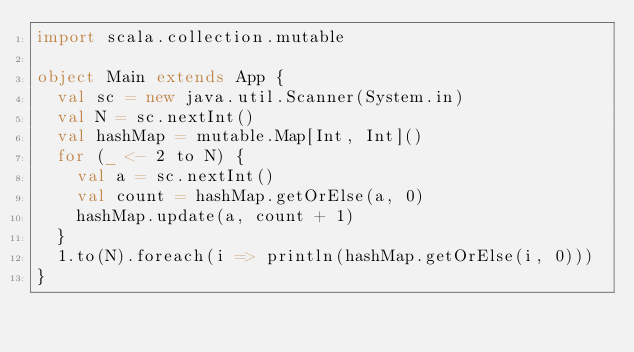Convert code to text. <code><loc_0><loc_0><loc_500><loc_500><_Scala_>import scala.collection.mutable
 
object Main extends App {
  val sc = new java.util.Scanner(System.in)
  val N = sc.nextInt()
  val hashMap = mutable.Map[Int, Int]()
  for (_ <- 2 to N) {
    val a = sc.nextInt()
    val count = hashMap.getOrElse(a, 0)
    hashMap.update(a, count + 1)
  }
  1.to(N).foreach(i => println(hashMap.getOrElse(i, 0)))
}</code> 